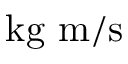Convert formula to latex. <formula><loc_0><loc_0><loc_500><loc_500>{ k g m } / { s }</formula> 